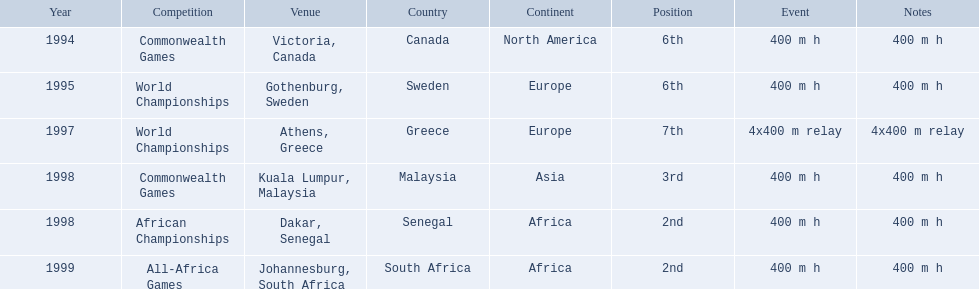What country was the 1997 championships held in? Athens, Greece. What long was the relay? 4x400 m relay. 